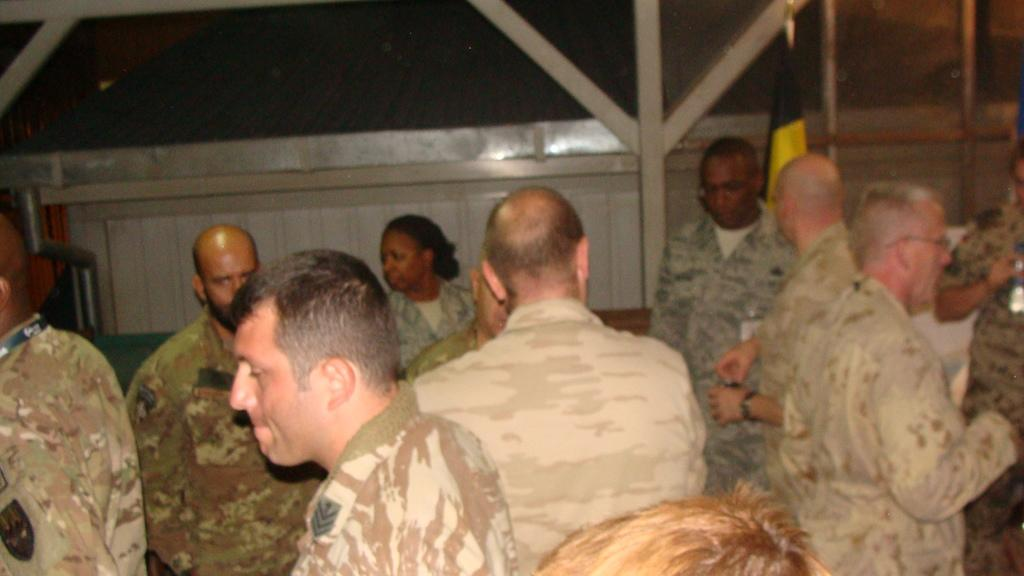Who or what can be seen in the image? There are people in the image. What can be seen in the background of the image? There is a wall, a flag, and an unspecified object in the background of the image. What type of vacation is the rabbit enjoying in the image? There is no rabbit present in the image, and therefore no vacation can be observed. 